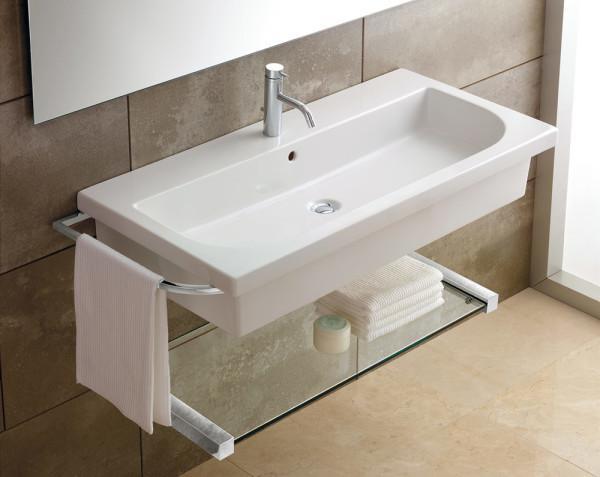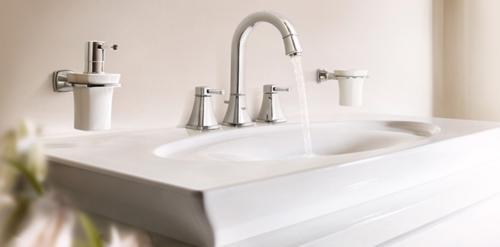The first image is the image on the left, the second image is the image on the right. Analyze the images presented: Is the assertion "One sink has a gooseneck faucet with a turned-down curved spout." valid? Answer yes or no. Yes. The first image is the image on the left, the second image is the image on the right. Assess this claim about the two images: "In one image, the chrome water spout is shaped like a rounded arc over the rectangular sink area.". Correct or not? Answer yes or no. Yes. 